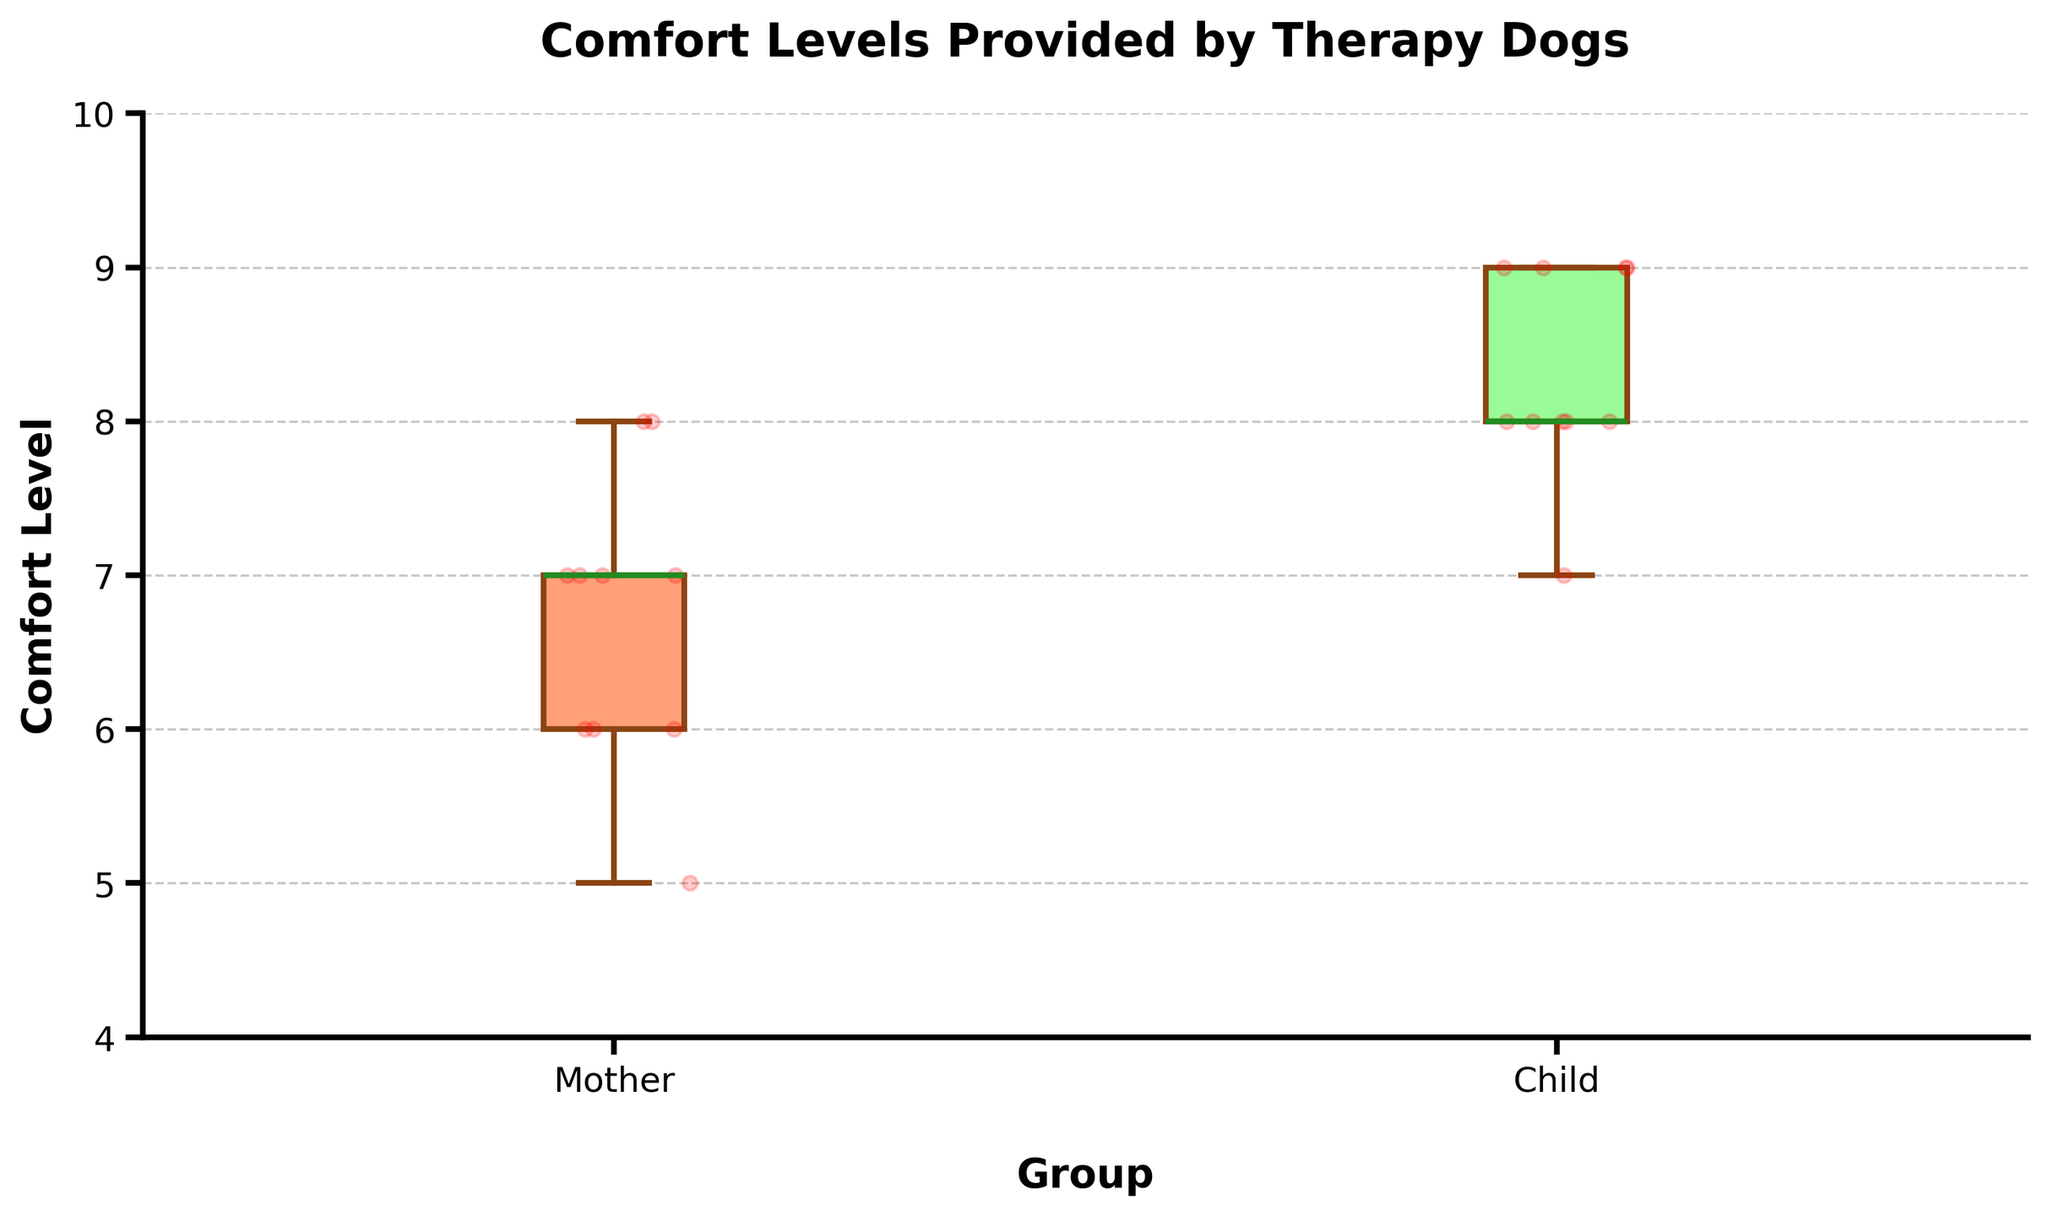what is the title of the plot? The title is displayed at the top of the plot in large, bold text.
Answer: Comfort Levels Provided by Therapy Dogs what are the labels on the x-axis? The x-axis labels are directly below each box and depict the groups being compared.
Answer: Mother and Child which group has the higher median comfort level? The median is indicated by the line inside each box. The median line for the Child group is higher than that for the Mother group.
Answer: Child what are the minimum and maximum comfort levels for mothers? The minimum and maximum comfort levels are indicated by the whiskers at either end of the boxes. For mothers, the minimum is 5 and the maximum is 8.
Answer: Minimum is 5, Maximum is 8 how many children reported a comfort level of 9? The red dots represent individual data points. For the Child group, count the dots positioned at 9. There are 3 such dots.
Answer: 3 compare the interquartile ranges (IQRs) of the two groups The IQR is the range between the top (Q3) and bottom (Q1) edges of each box. The Child group's IQR is from 8 to 9, while the Mother group's IQR is from 6 to 7.
Answer: Children: 8 to 9, Mothers: 6 to 7 what does the box color represent in the plot? The colors of the boxes differentiate between the two groups, with the Mother's box in salmon color and the Child's box in light green color.
Answer: Mother's box in salmon, Child's box in light green how many data points are plotted for each group? Each red dot represents an individual data point. Counting them for each group shows both groups have 10 data points.
Answer: 10 data points each which group has greater variability in comfort levels? Variability is indicated by the length of the whiskers and the spread of the dots. The spread is larger for the Mother group (5-8) than for the Child group (7-9).
Answer: Mother are there any outliers in the dataset? Outliers would typically be indicated by dots outside the whiskers. There are no dots beyond the whiskers in this plot, indicating no outliers.
Answer: No 